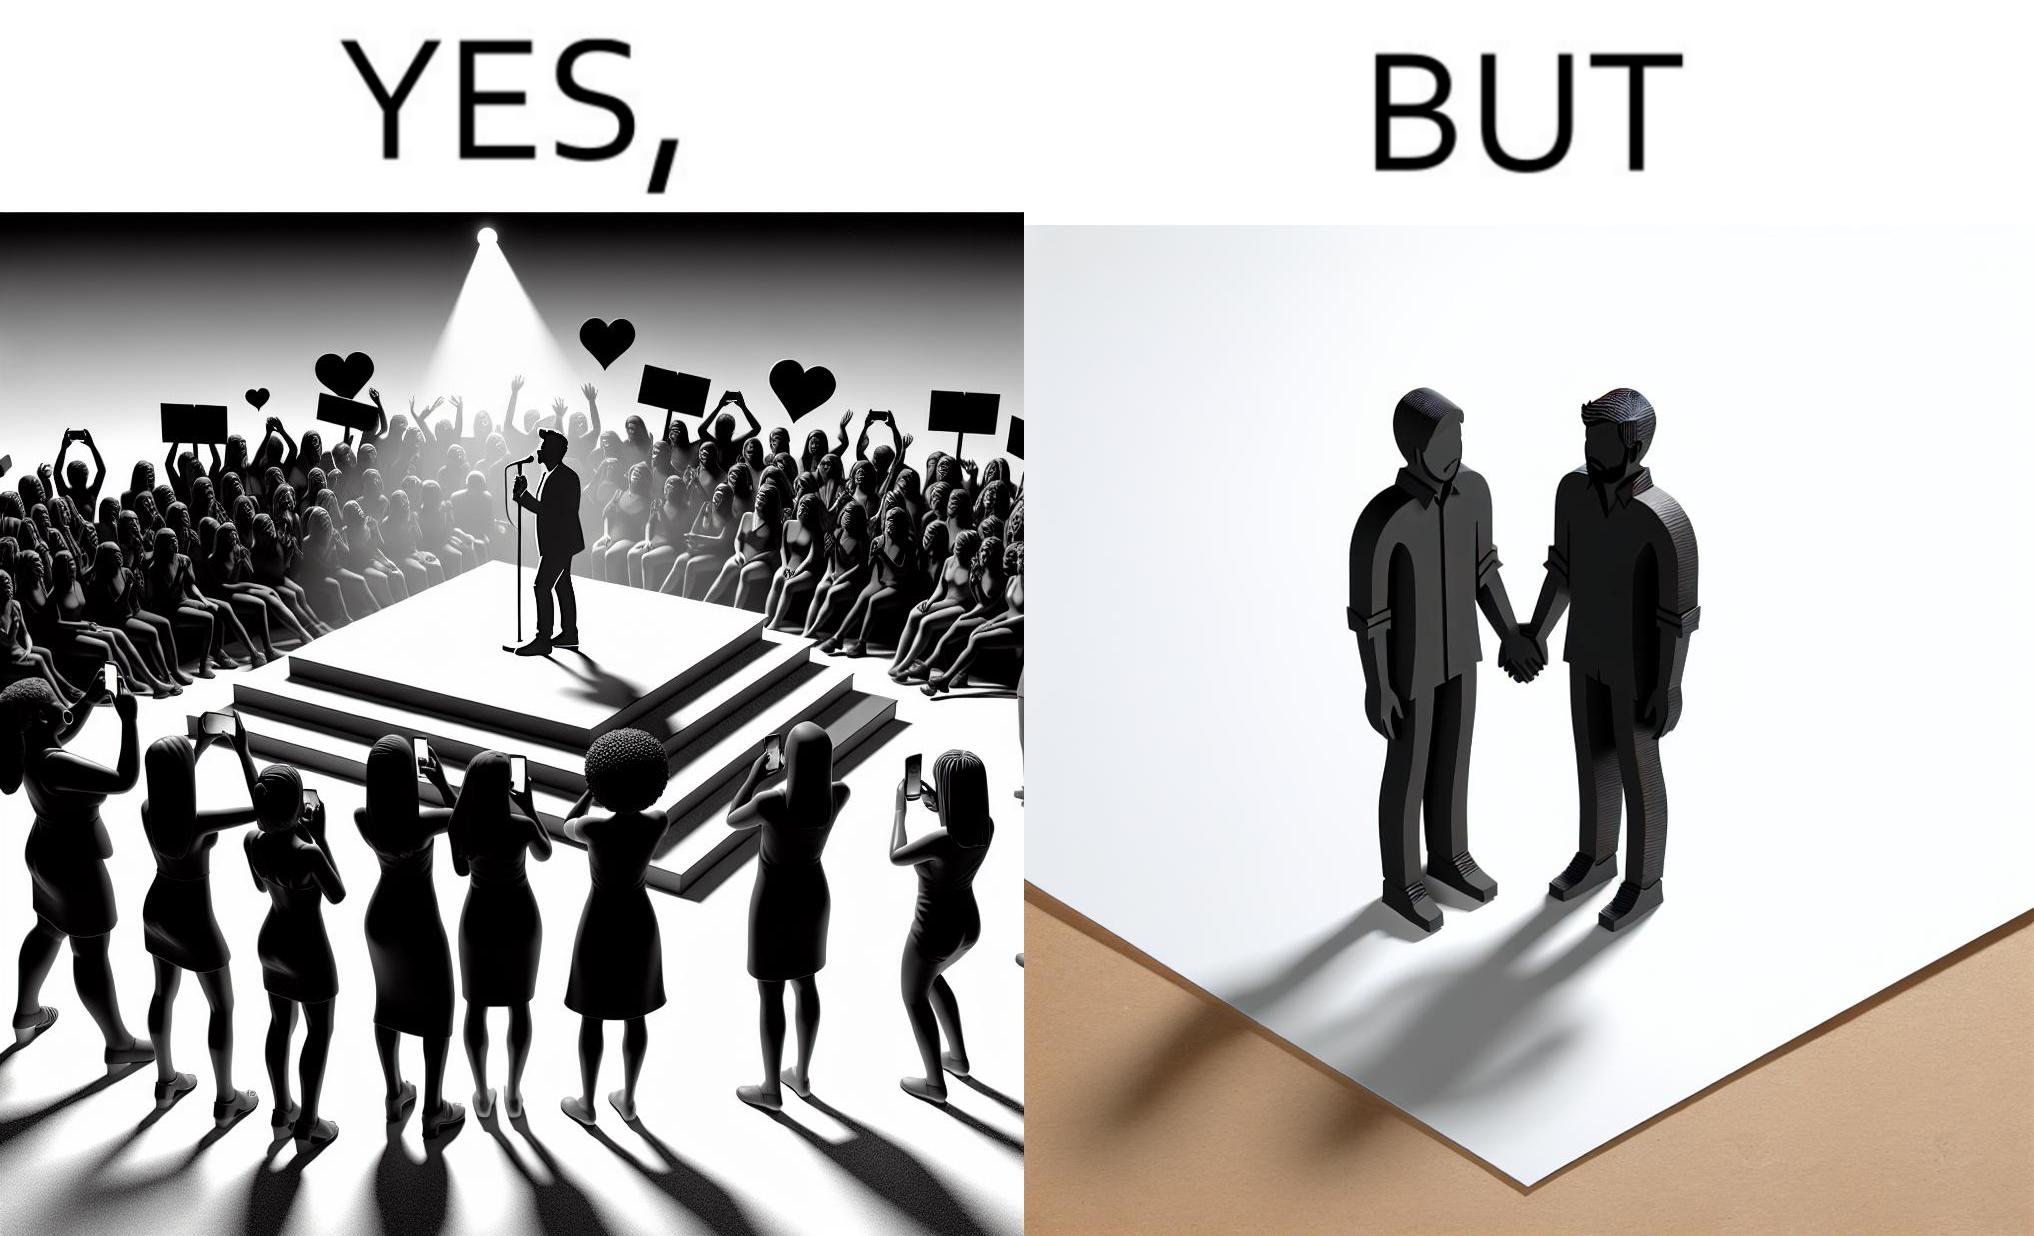Why is this image considered satirical? The image is funny because while the girls loves the man, he likes other men instead of women. 